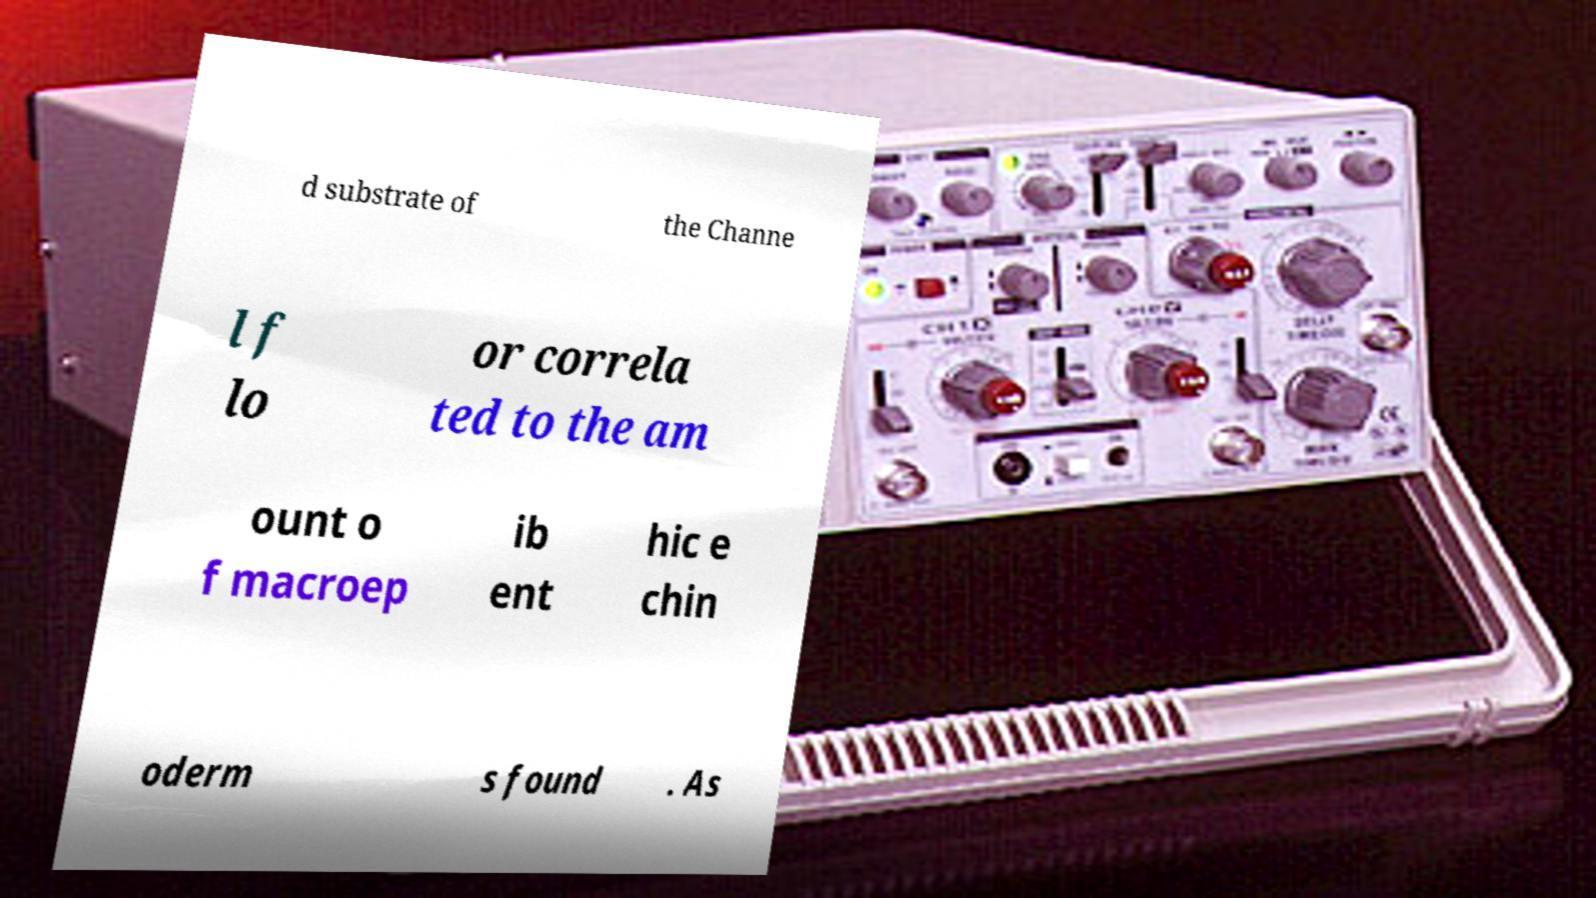Please read and relay the text visible in this image. What does it say? d substrate of the Channe l f lo or correla ted to the am ount o f macroep ib ent hic e chin oderm s found . As 